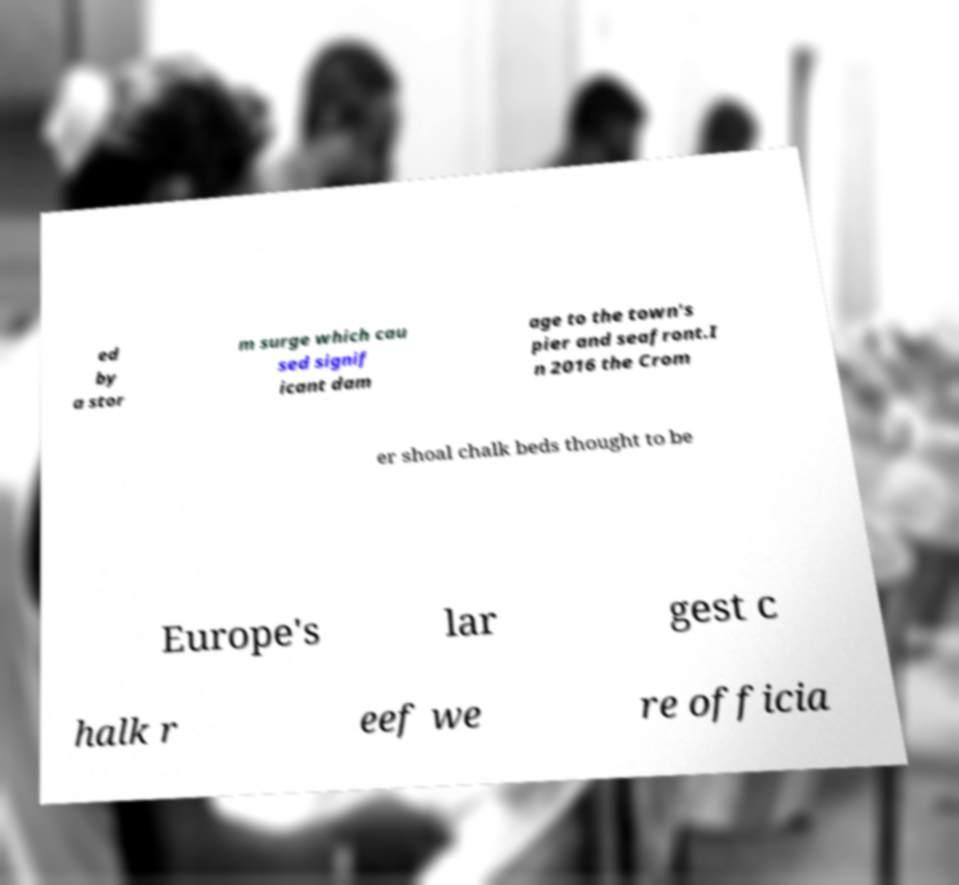Could you extract and type out the text from this image? ed by a stor m surge which cau sed signif icant dam age to the town's pier and seafront.I n 2016 the Crom er shoal chalk beds thought to be Europe's lar gest c halk r eef we re officia 